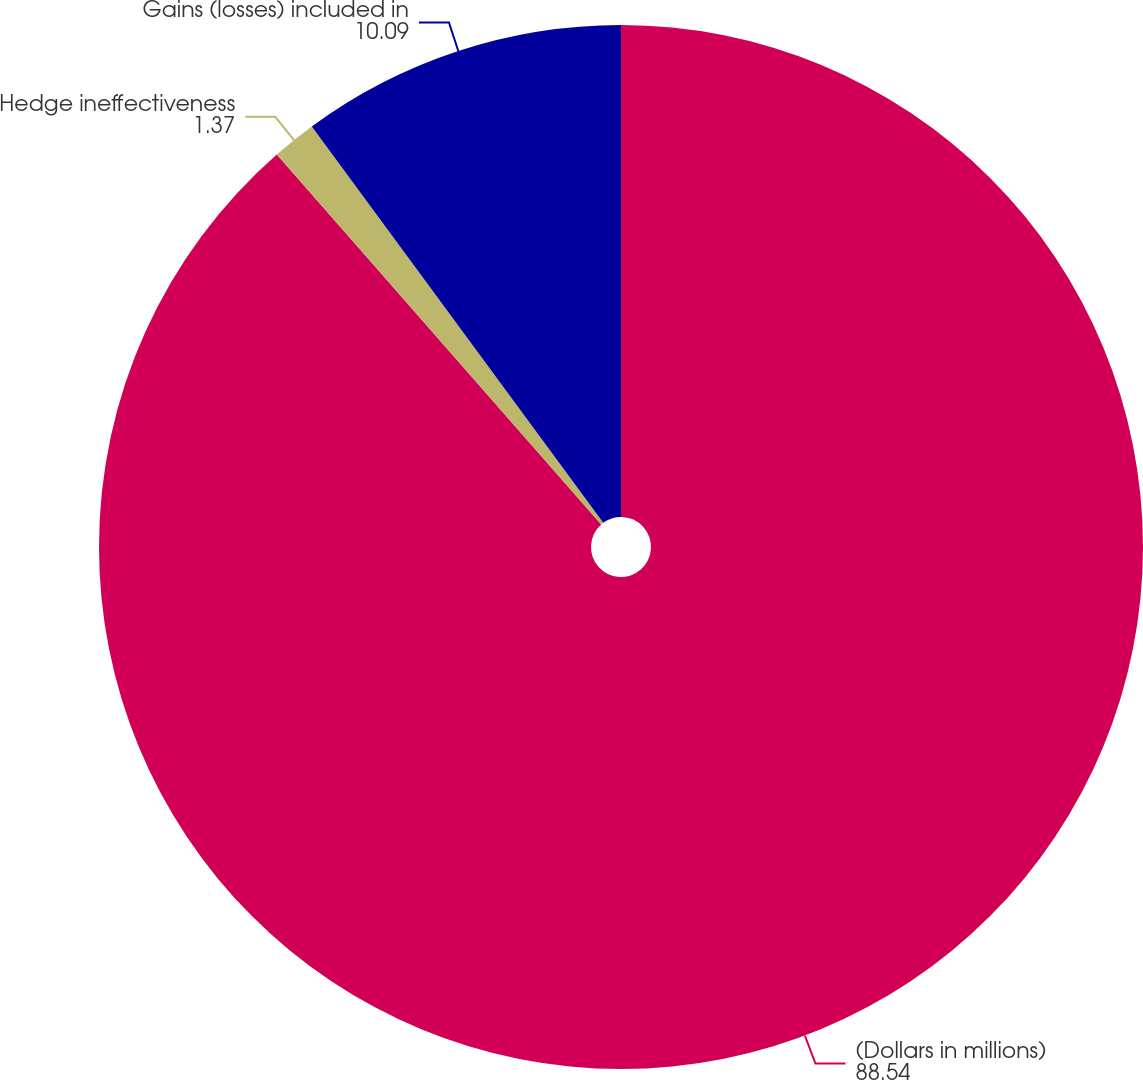<chart> <loc_0><loc_0><loc_500><loc_500><pie_chart><fcel>(Dollars in millions)<fcel>Hedge ineffectiveness<fcel>Gains (losses) included in<nl><fcel>88.54%<fcel>1.37%<fcel>10.09%<nl></chart> 